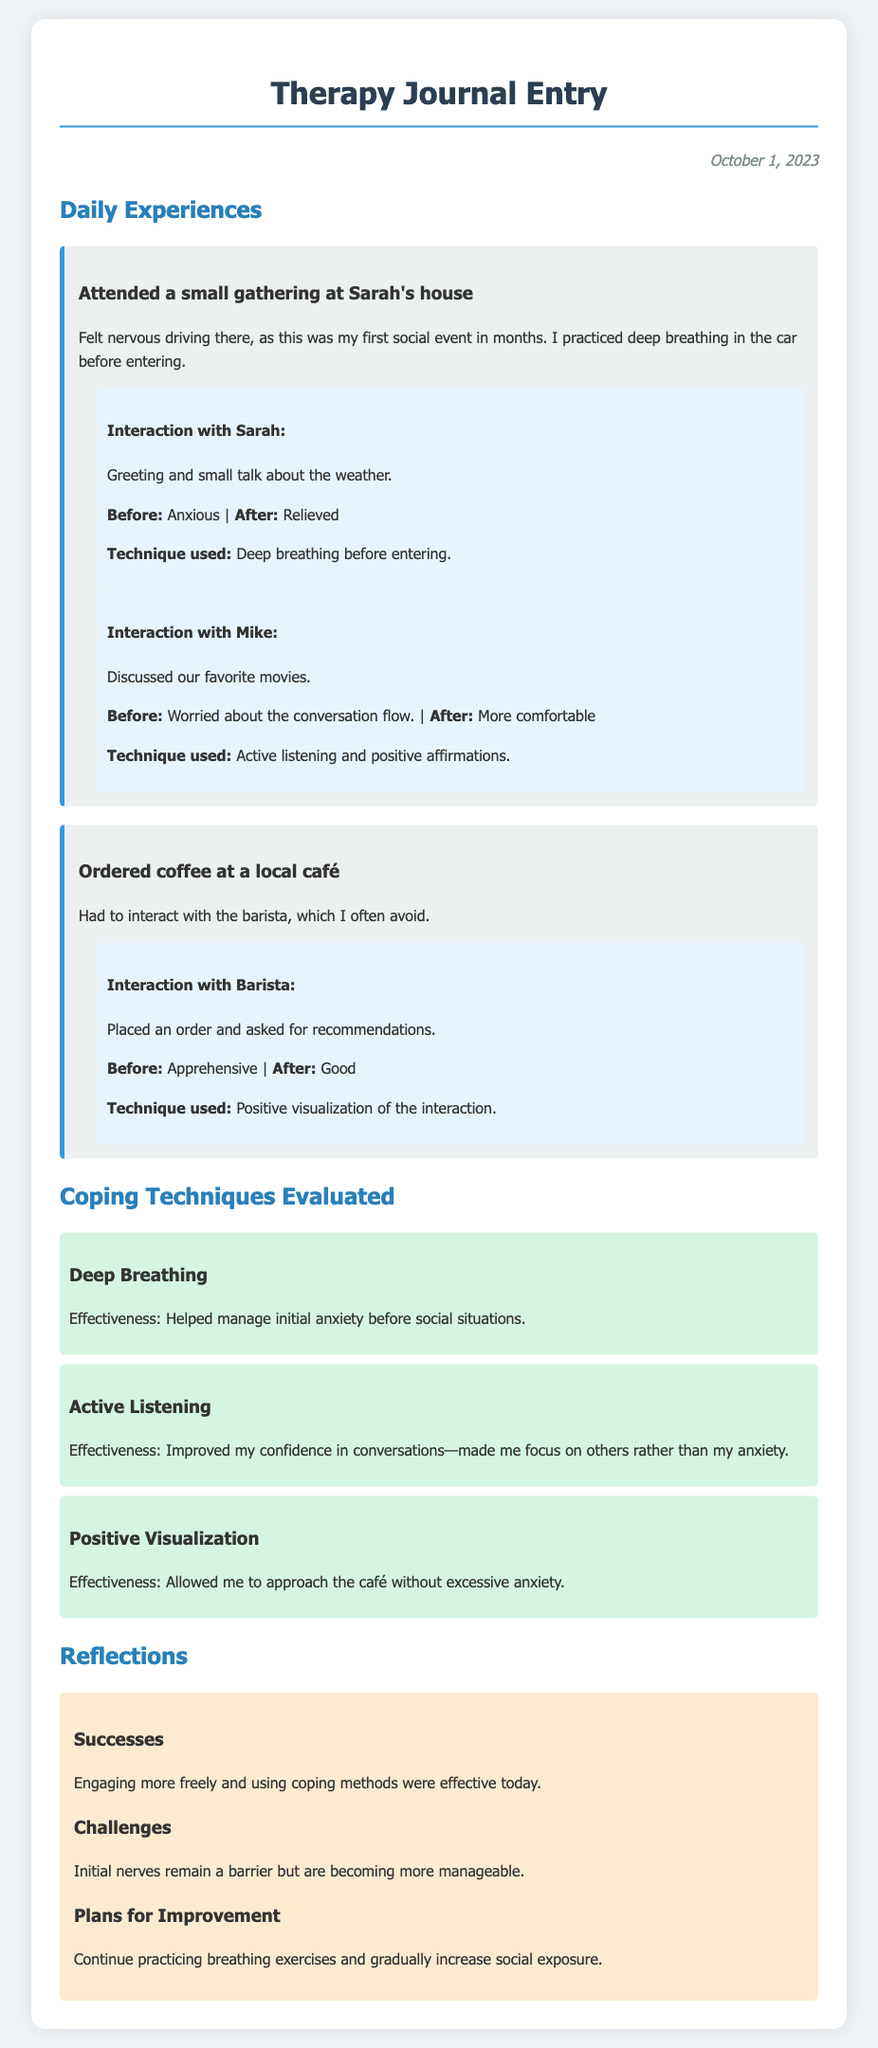What date is the journal entry from? The date mentioned in the journal entry is "October 1, 2023."
Answer: October 1, 2023 Who hosted the first social event documented? The first social event was hosted by Sarah.
Answer: Sarah What coping technique was used before interacting with Sarah? The coping technique used before interacting with Sarah was deep breathing.
Answer: Deep breathing How did the interaction with the barista make the author feel after? The feeling after interacting with the barista was described as "Good."
Answer: Good What is one challenge noted in the reflections? One challenge mentioned in the reflections is "Initial nerves remain a barrier."
Answer: Initial nerves remain a barrier How did the author evaluate the effectiveness of active listening? The author evaluated the effectiveness of active listening as something that improved confidence in conversations.
Answer: Improved my confidence in conversations What does the author plan to continue practicing for improvement? The author plans to continue practicing breathing exercises.
Answer: Breathing exercises 